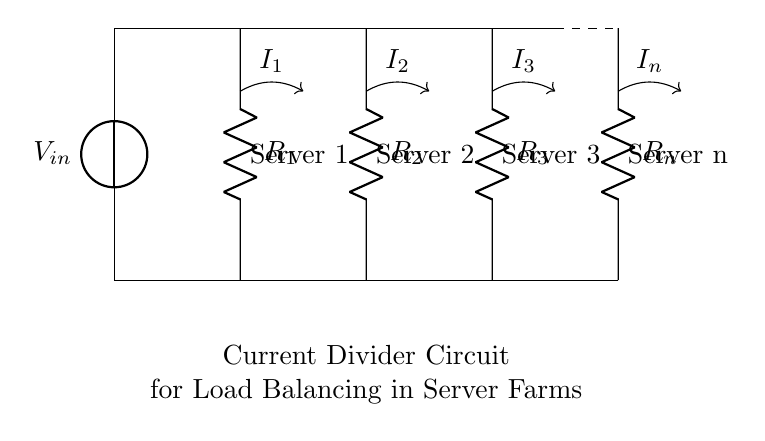What is the input voltage for this circuit? The input voltage is labeled as V_in at the top of the circuit diagram.
Answer: V_in How many resistors are present in the circuit? There are four resistors labeled R_1, R_2, R_3, and R_n, which can be counted directly from the diagram.
Answer: 4 What is the relationship between the currents I_1, I_2, I_3, and I_n? The currents I_1, I_2, I_3, and I_n are all part of a current divider; they share the same voltage across them and their magnitudes are inversely proportional to their resistances.
Answer: Divided currents Which server corresponds to resistor R_2? Resistor R_2 is directly labeled in the diagram associated with Server 2, indicating their relationship.
Answer: Server 2 If the resistances R_1, R_2, R_3, and R_n are equal, how will the currents I_1, I_2, I_3, and I_n compare? When all resistors are equal, the current through each resistor will be equal as well because a current divider splits the current inversely proportional to their resistances.
Answer: Equal current What design purpose does this current divider serve in a server farm? The current divider is used for load balancing, distributing the current equally among the servers to prevent overload on any single server.
Answer: Load balancing 